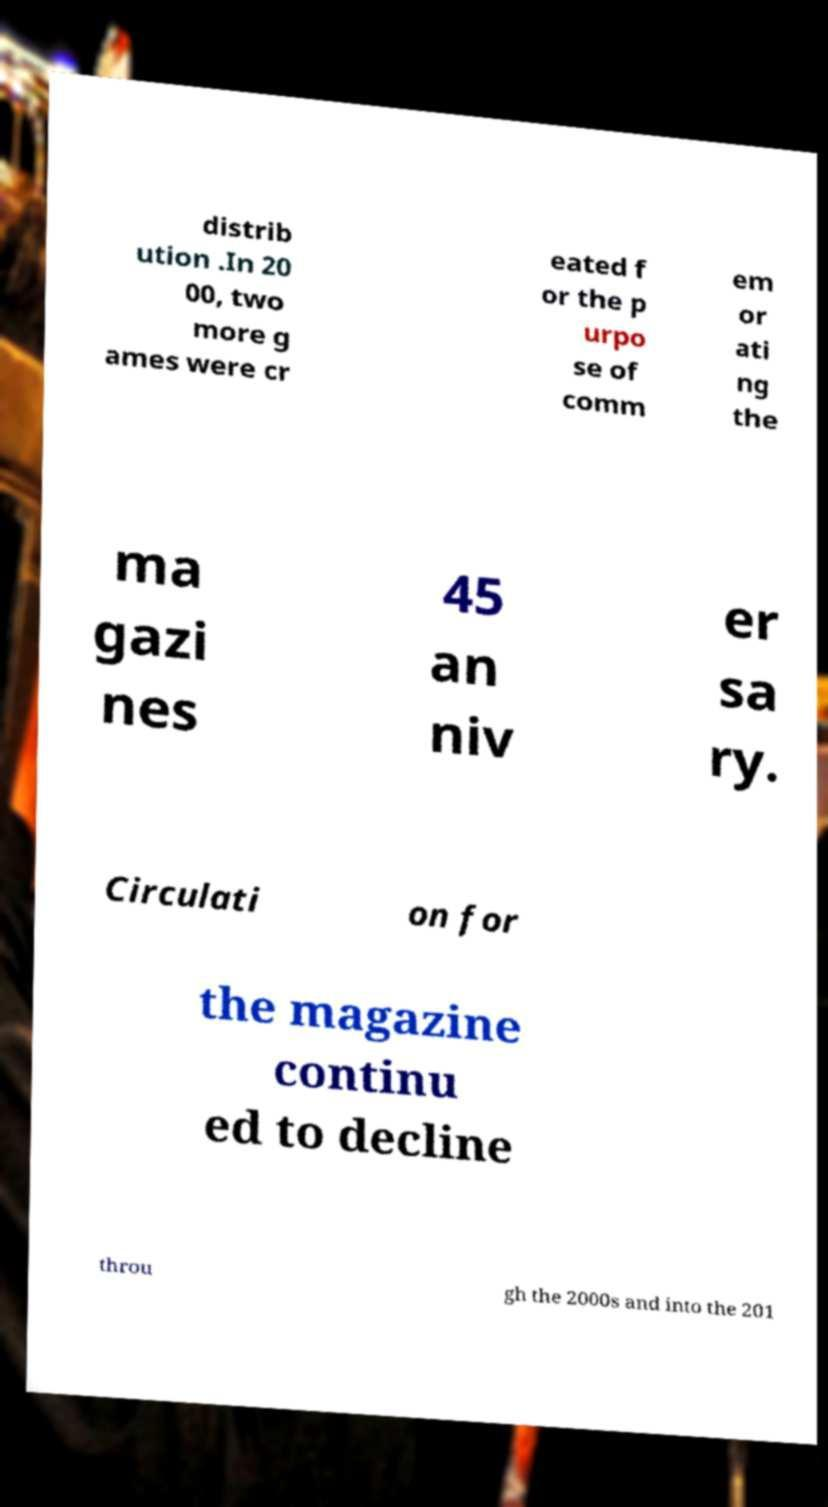For documentation purposes, I need the text within this image transcribed. Could you provide that? distrib ution .In 20 00, two more g ames were cr eated f or the p urpo se of comm em or ati ng the ma gazi nes 45 an niv er sa ry. Circulati on for the magazine continu ed to decline throu gh the 2000s and into the 201 